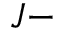Convert formula to latex. <formula><loc_0><loc_0><loc_500><loc_500>J -</formula> 